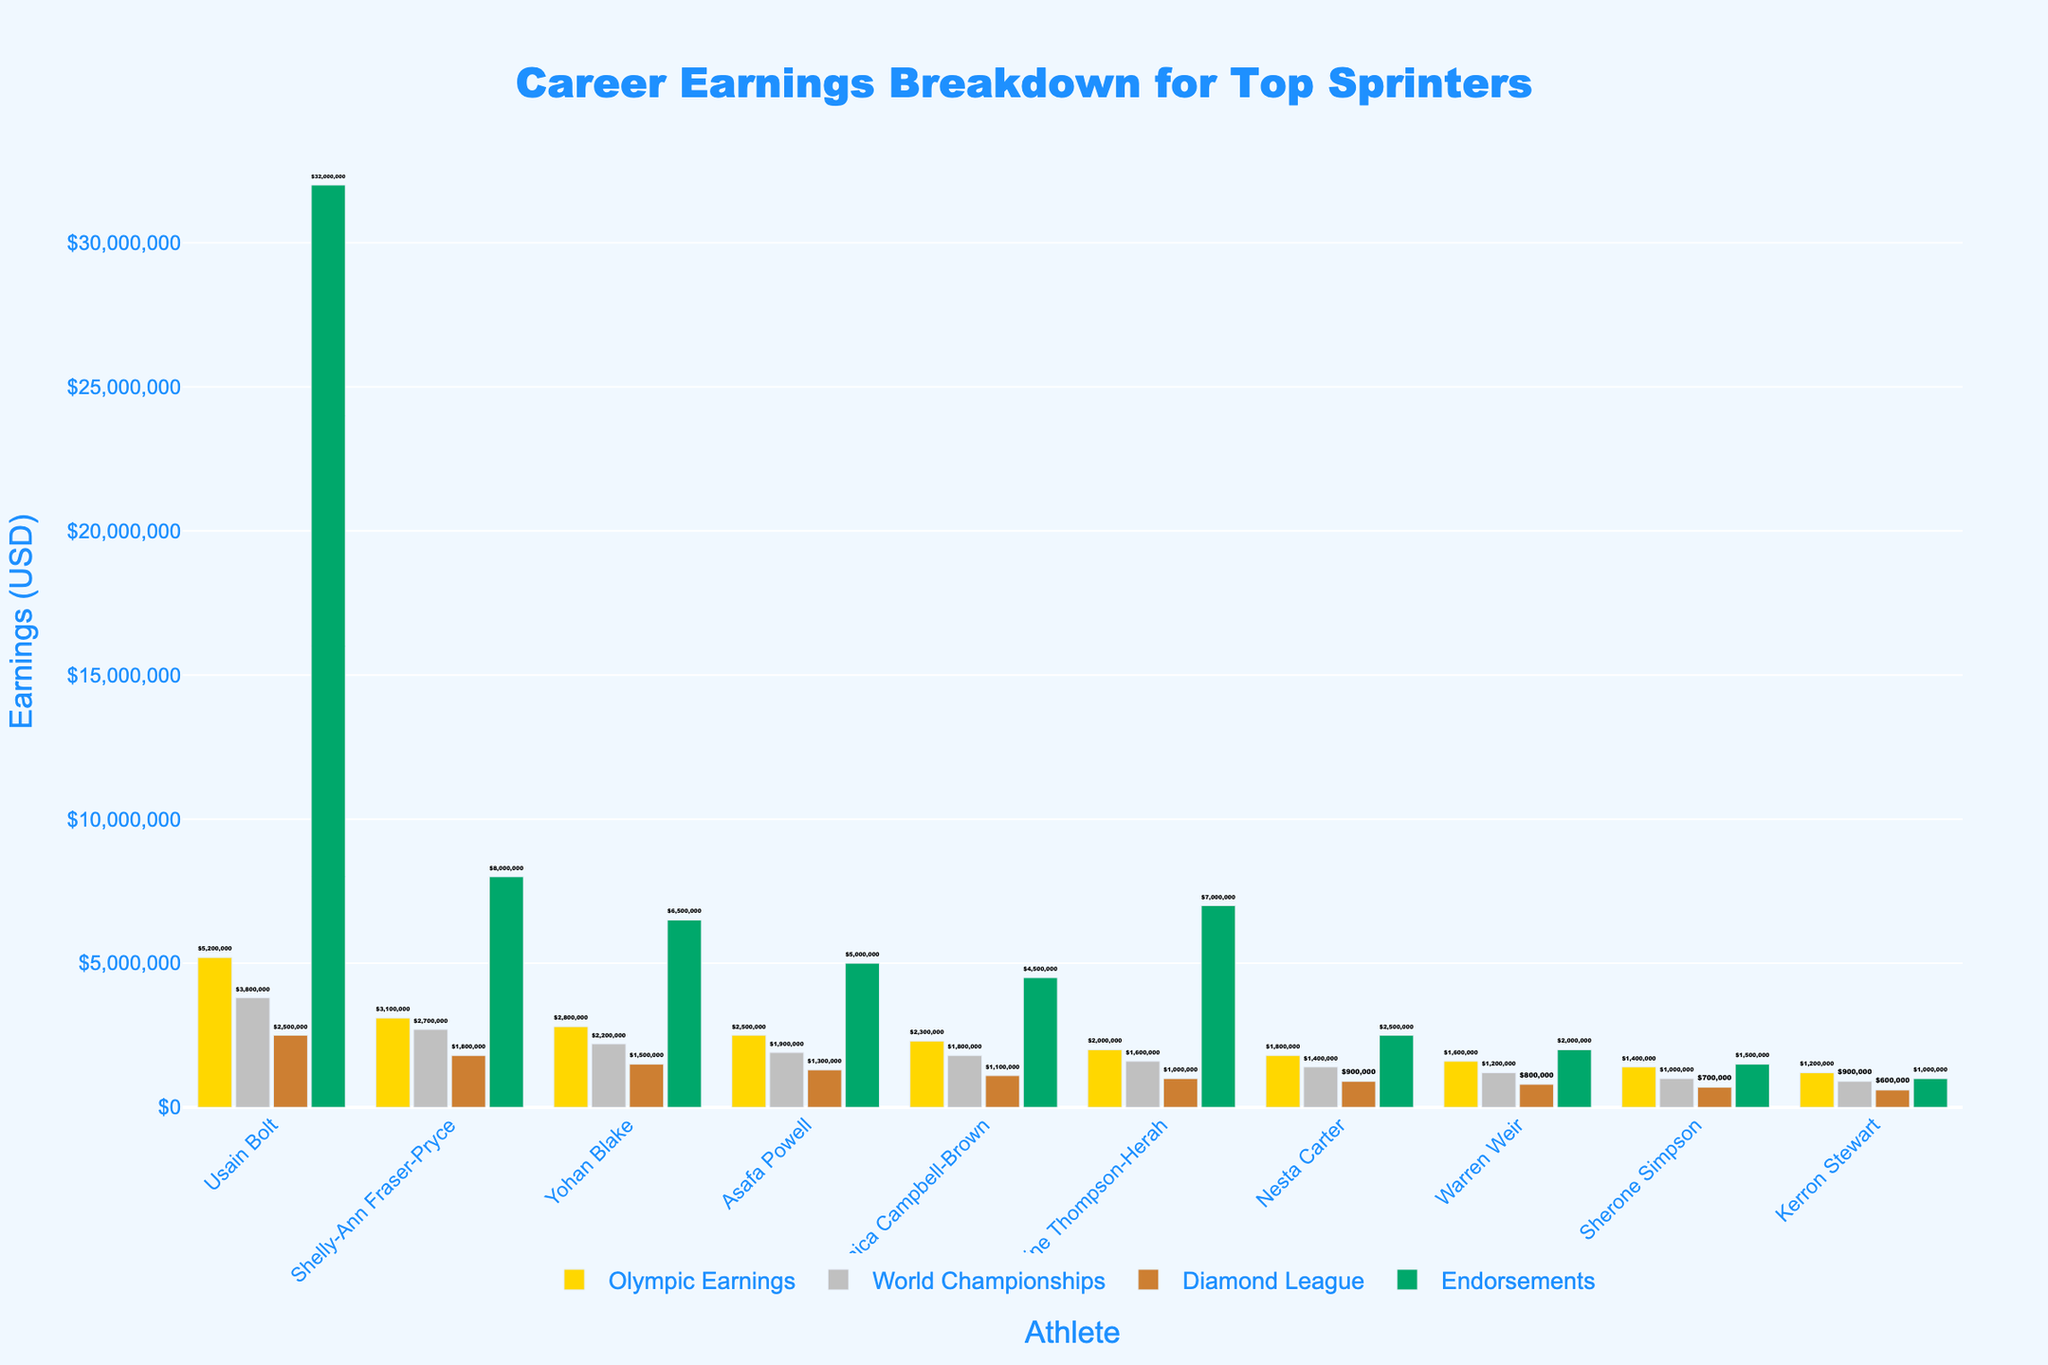1. Which athlete has the highest total career earnings? Usain Bolt has the highest career earnings by examining all the categories where his endorsements contribute significantly. Adding up his earnings (Olympic: $5,200,000, World Championships: $3,800,000, Diamond League: $2,500,000, Endorsements: $32,000,000) results in a total of $43,500,000.
Answer: Usain Bolt 2. What is the combined earnings of Yohan Blake from Olympic Earnings and Diamond League? Adding Yohan Blake's earnings from the Olympics ($2,800,000) and Diamond League ($1,500,000) gives a sum of $4,300,000.
Answer: $4,300,000 3. How much more does Shelley-Ann Fraser-Pryce earn from endorsements compared to Asafa Powell? Shelly-Ann Fraser-Pryce earns $8,000,000 from endorsements, while Asafa Powell earns $5,000,000. The difference is $8,000,000 - $5,000,000 = $3,000,000.
Answer: $3,000,000 4. Who earns more from World Championships, Nesta Carter or Warren Weir? Nesta Carter has higher earnings from World Championships ($1,400,000) compared to Warren Weir ($1,200,000).
Answer: Nesta Carter 5. Which earnings category contributes the most to Kerron Stewart's overall earnings? Examining Kerron Stewart’s earnings, endorsements contribute the most with $1,000,000, which is more than each of the other categories (Olympic: $1,200,000, World Championships: $900,000, Diamond League: $600,000).
Answer: Endorsements 6. Among the athletes, who has the least earning from the Diamond League? Kerron Stewart has the least earnings from the Diamond League, with $600,000.
Answer: Kerron Stewart 7. By how much do Shelly-Ann Fraser-Pryce's Olympic earnings exceed her World Championships earnings? Shelly-Ann Fraser-Pryce’s Olympic earnings are $3,100,000, while her World Championships earnings are $2,700,000. The difference is $3,100,000 - $2,700,000 = $400,000.
Answer: $400,000 8. How does the total earnings of Elaine Thompson-Herah from Diamond League and World Championships compare to Asafa Powell from the same categories? Elaine Thompson-Herah’s earnings from Diamond League ($1,000,000) and World Championships ($1,600,000) total to $2,600,000. Asafa Powell earns $1,300,000 from Diamond League and $1,900,000 from World Championships, totaling $3,200,000. Asafa Powell earns more by $3,200,000 - $2,600,000 = $600,000.
Answer: Asafa Powell 9. What is the ratio of Usain Bolt’s endorsements to his total Olympic earnings? Usain Bolt’s endorsements amount to $32,000,000, and his Olympic earnings are $5,200,000. The ratio is $32,000,000 : $5,200,000, which simplifies to approximately 6.15 : 1.
Answer: 6.15 : 1 